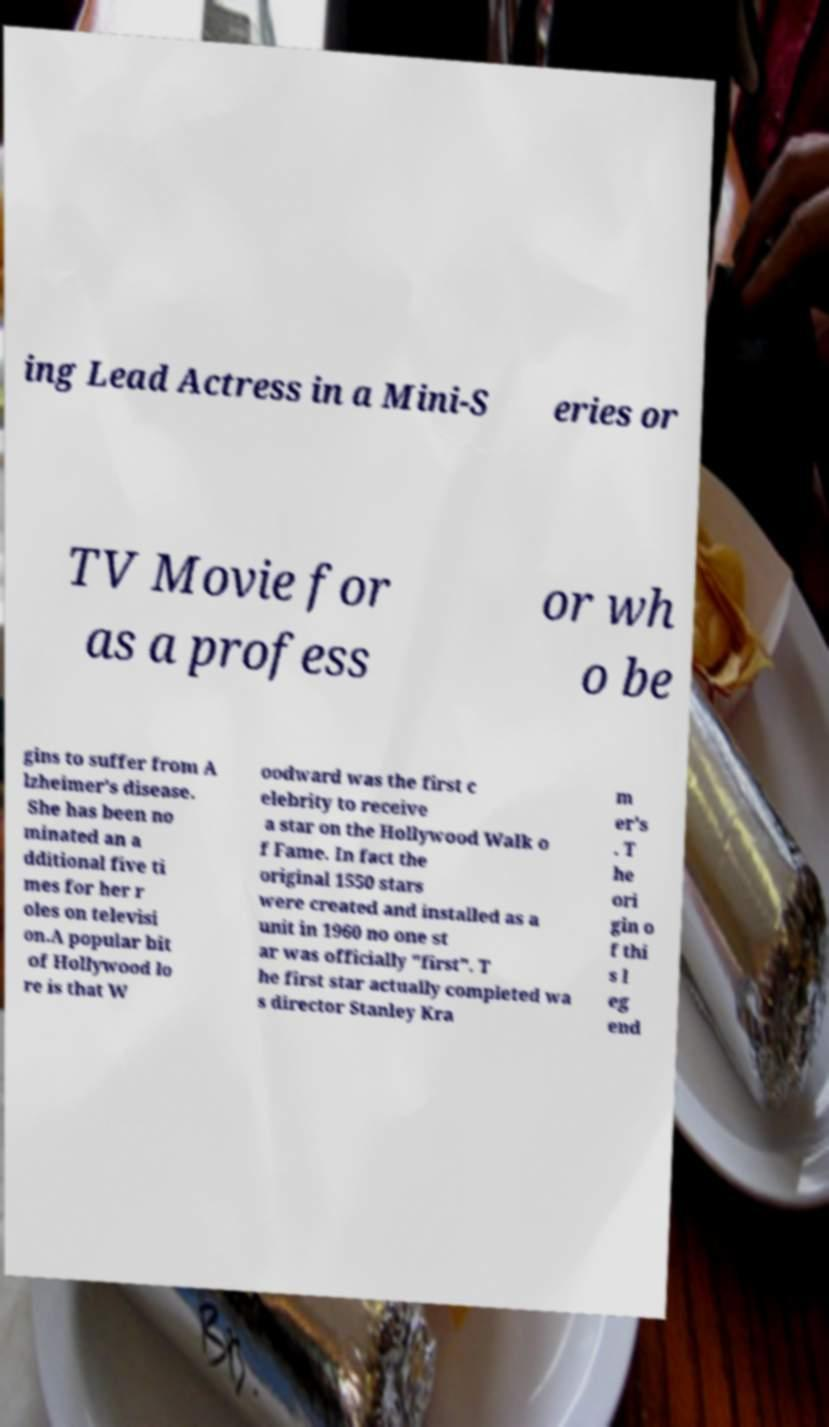There's text embedded in this image that I need extracted. Can you transcribe it verbatim? ing Lead Actress in a Mini-S eries or TV Movie for as a profess or wh o be gins to suffer from A lzheimer's disease. She has been no minated an a dditional five ti mes for her r oles on televisi on.A popular bit of Hollywood lo re is that W oodward was the first c elebrity to receive a star on the Hollywood Walk o f Fame. In fact the original 1550 stars were created and installed as a unit in 1960 no one st ar was officially "first". T he first star actually completed wa s director Stanley Kra m er's . T he ori gin o f thi s l eg end 